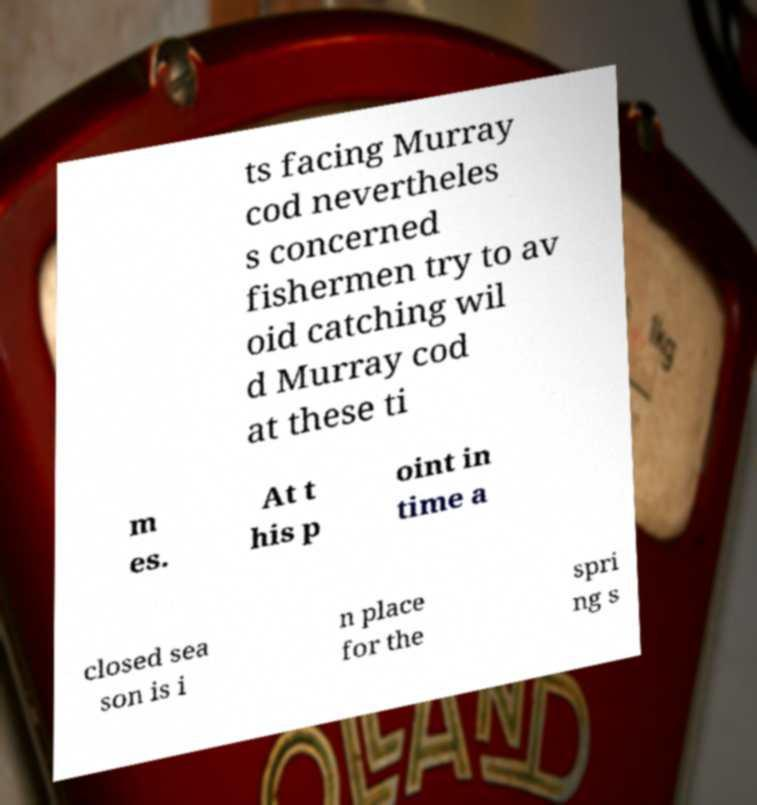Can you read and provide the text displayed in the image?This photo seems to have some interesting text. Can you extract and type it out for me? ts facing Murray cod nevertheles s concerned fishermen try to av oid catching wil d Murray cod at these ti m es. At t his p oint in time a closed sea son is i n place for the spri ng s 